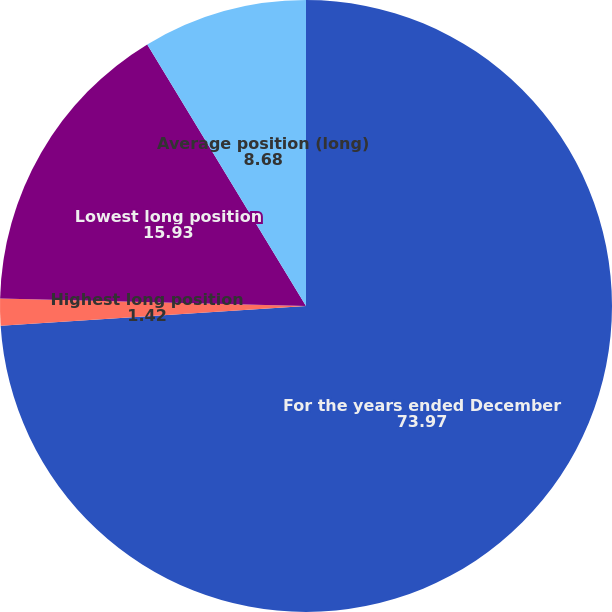Convert chart to OTSL. <chart><loc_0><loc_0><loc_500><loc_500><pie_chart><fcel>For the years ended December<fcel>Highest long position<fcel>Lowest long position<fcel>Average position (long)<nl><fcel>73.97%<fcel>1.42%<fcel>15.93%<fcel>8.68%<nl></chart> 